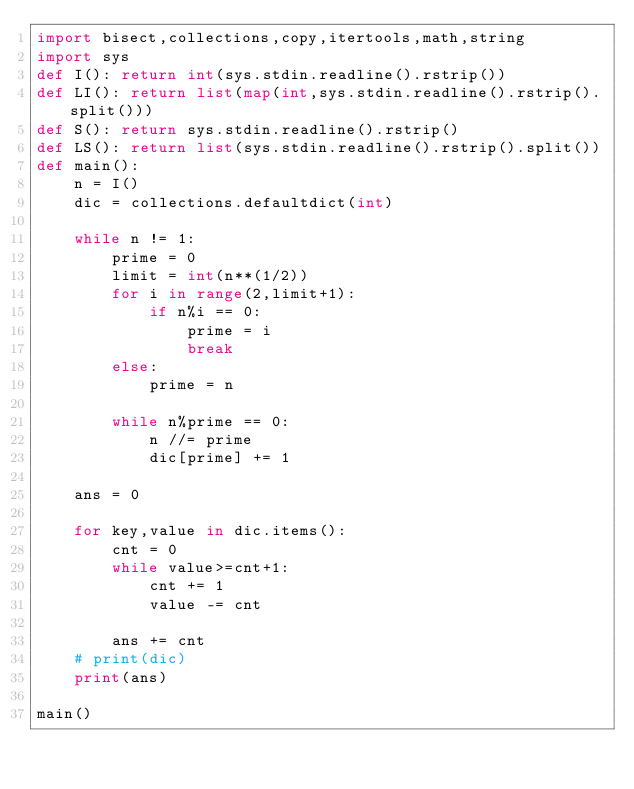<code> <loc_0><loc_0><loc_500><loc_500><_Python_>import bisect,collections,copy,itertools,math,string
import sys
def I(): return int(sys.stdin.readline().rstrip())
def LI(): return list(map(int,sys.stdin.readline().rstrip().split()))
def S(): return sys.stdin.readline().rstrip()
def LS(): return list(sys.stdin.readline().rstrip().split())
def main():
    n = I()
    dic = collections.defaultdict(int)

    while n != 1:
        prime = 0
        limit = int(n**(1/2))
        for i in range(2,limit+1):
            if n%i == 0:
                prime = i
                break
        else:
            prime = n

        while n%prime == 0:
            n //= prime
            dic[prime] += 1

    ans = 0

    for key,value in dic.items():
        cnt = 0
        while value>=cnt+1:
            cnt += 1
            value -= cnt

        ans += cnt
    # print(dic)
    print(ans)
        
main()            
</code> 